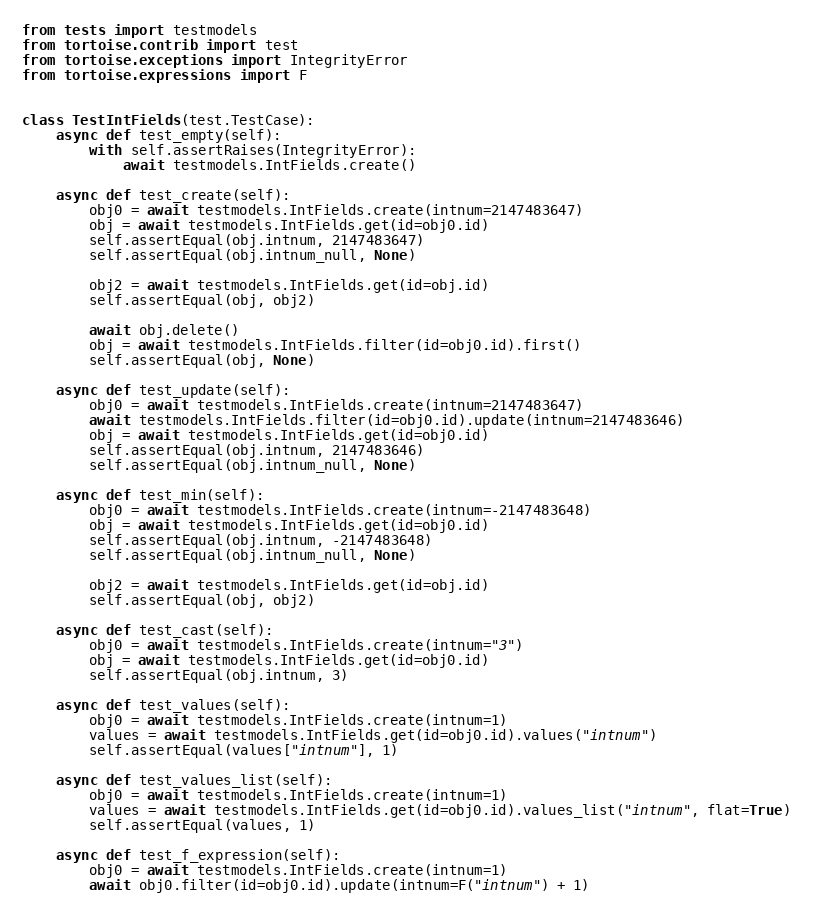Convert code to text. <code><loc_0><loc_0><loc_500><loc_500><_Python_>from tests import testmodels
from tortoise.contrib import test
from tortoise.exceptions import IntegrityError
from tortoise.expressions import F


class TestIntFields(test.TestCase):
    async def test_empty(self):
        with self.assertRaises(IntegrityError):
            await testmodels.IntFields.create()

    async def test_create(self):
        obj0 = await testmodels.IntFields.create(intnum=2147483647)
        obj = await testmodels.IntFields.get(id=obj0.id)
        self.assertEqual(obj.intnum, 2147483647)
        self.assertEqual(obj.intnum_null, None)

        obj2 = await testmodels.IntFields.get(id=obj.id)
        self.assertEqual(obj, obj2)

        await obj.delete()
        obj = await testmodels.IntFields.filter(id=obj0.id).first()
        self.assertEqual(obj, None)

    async def test_update(self):
        obj0 = await testmodels.IntFields.create(intnum=2147483647)
        await testmodels.IntFields.filter(id=obj0.id).update(intnum=2147483646)
        obj = await testmodels.IntFields.get(id=obj0.id)
        self.assertEqual(obj.intnum, 2147483646)
        self.assertEqual(obj.intnum_null, None)

    async def test_min(self):
        obj0 = await testmodels.IntFields.create(intnum=-2147483648)
        obj = await testmodels.IntFields.get(id=obj0.id)
        self.assertEqual(obj.intnum, -2147483648)
        self.assertEqual(obj.intnum_null, None)

        obj2 = await testmodels.IntFields.get(id=obj.id)
        self.assertEqual(obj, obj2)

    async def test_cast(self):
        obj0 = await testmodels.IntFields.create(intnum="3")
        obj = await testmodels.IntFields.get(id=obj0.id)
        self.assertEqual(obj.intnum, 3)

    async def test_values(self):
        obj0 = await testmodels.IntFields.create(intnum=1)
        values = await testmodels.IntFields.get(id=obj0.id).values("intnum")
        self.assertEqual(values["intnum"], 1)

    async def test_values_list(self):
        obj0 = await testmodels.IntFields.create(intnum=1)
        values = await testmodels.IntFields.get(id=obj0.id).values_list("intnum", flat=True)
        self.assertEqual(values, 1)

    async def test_f_expression(self):
        obj0 = await testmodels.IntFields.create(intnum=1)
        await obj0.filter(id=obj0.id).update(intnum=F("intnum") + 1)</code> 